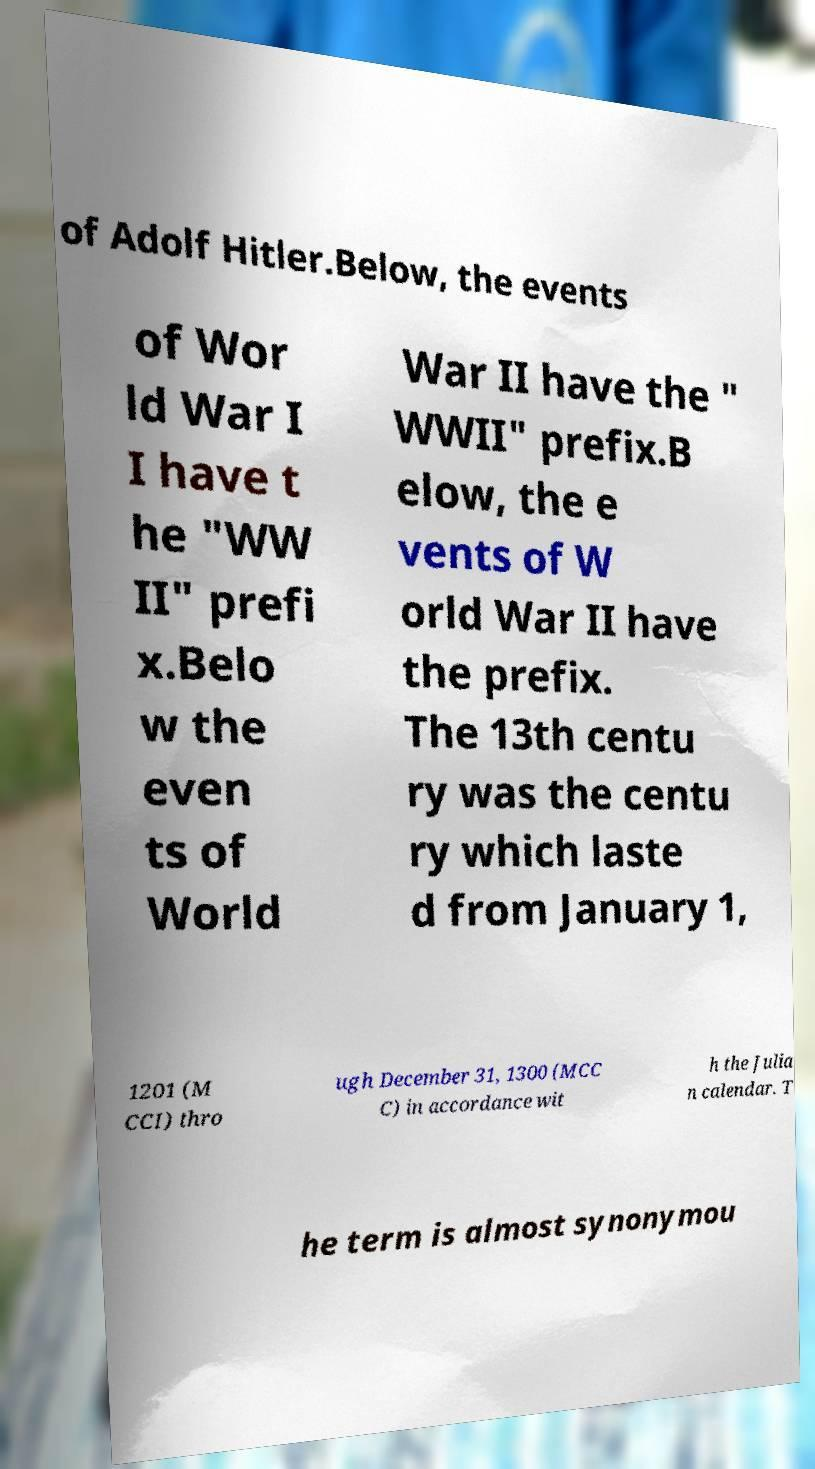Could you assist in decoding the text presented in this image and type it out clearly? of Adolf Hitler.Below, the events of Wor ld War I I have t he "WW II" prefi x.Belo w the even ts of World War II have the " WWII" prefix.B elow, the e vents of W orld War II have the prefix. The 13th centu ry was the centu ry which laste d from January 1, 1201 (M CCI) thro ugh December 31, 1300 (MCC C) in accordance wit h the Julia n calendar. T he term is almost synonymou 